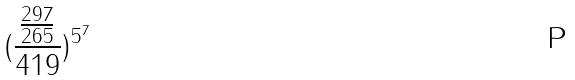Convert formula to latex. <formula><loc_0><loc_0><loc_500><loc_500>( \frac { \frac { 2 9 7 } { 2 6 5 } } { 4 1 9 } ) ^ { 5 ^ { 7 } }</formula> 